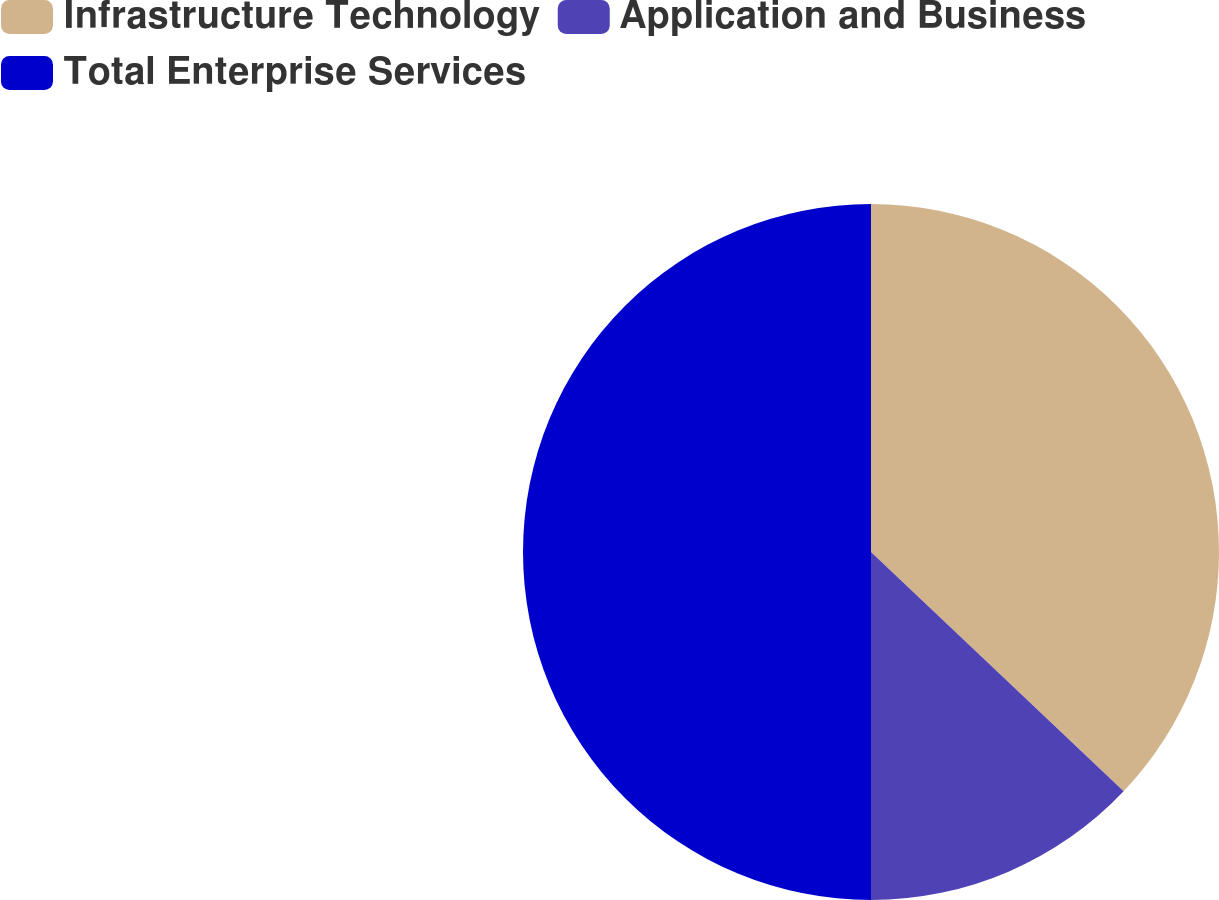<chart> <loc_0><loc_0><loc_500><loc_500><pie_chart><fcel>Infrastructure Technology<fcel>Application and Business<fcel>Total Enterprise Services<nl><fcel>37.07%<fcel>12.93%<fcel>50.0%<nl></chart> 